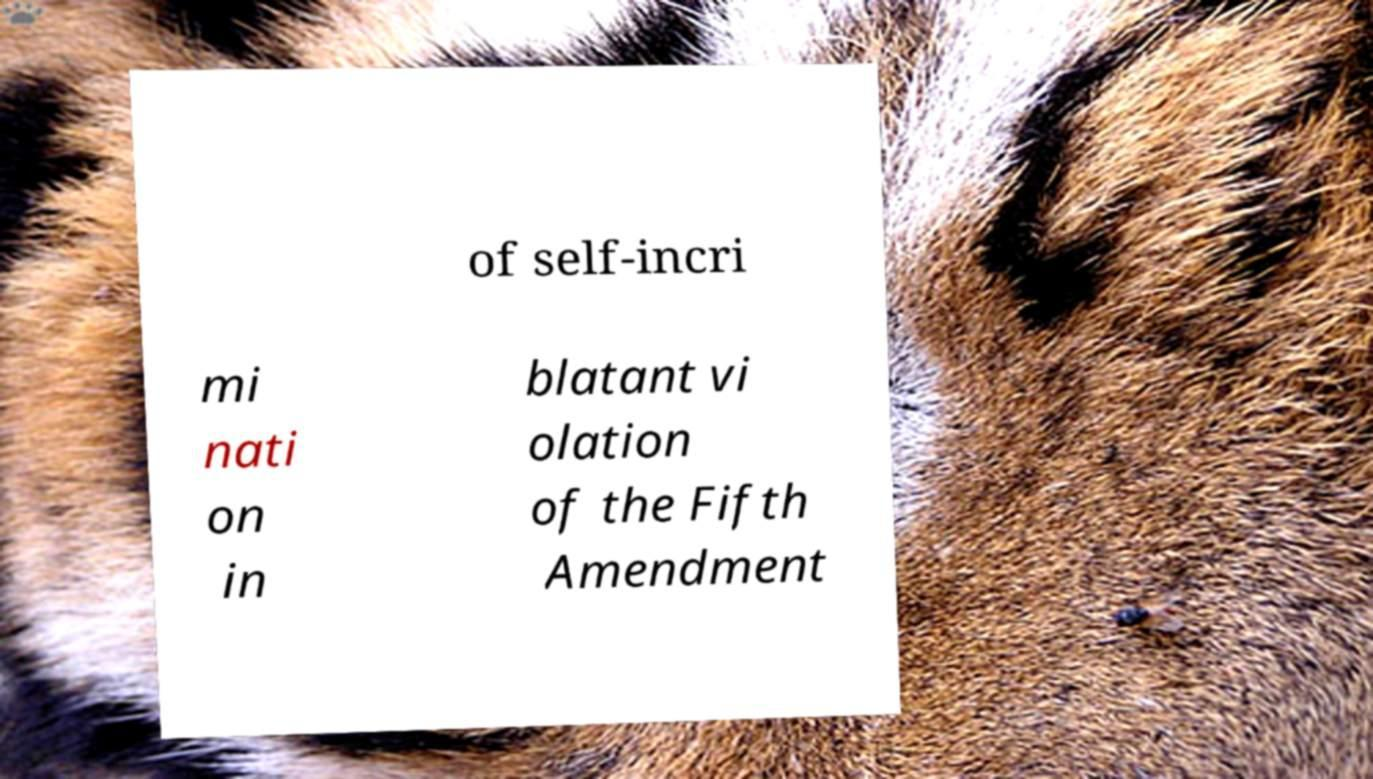For documentation purposes, I need the text within this image transcribed. Could you provide that? of self-incri mi nati on in blatant vi olation of the Fifth Amendment 